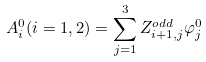<formula> <loc_0><loc_0><loc_500><loc_500>A _ { i } ^ { 0 } ( i = 1 , 2 ) = \sum _ { j = 1 } ^ { 3 } Z ^ { o d d } _ { i + 1 , j } \varphi _ { j } ^ { 0 }</formula> 